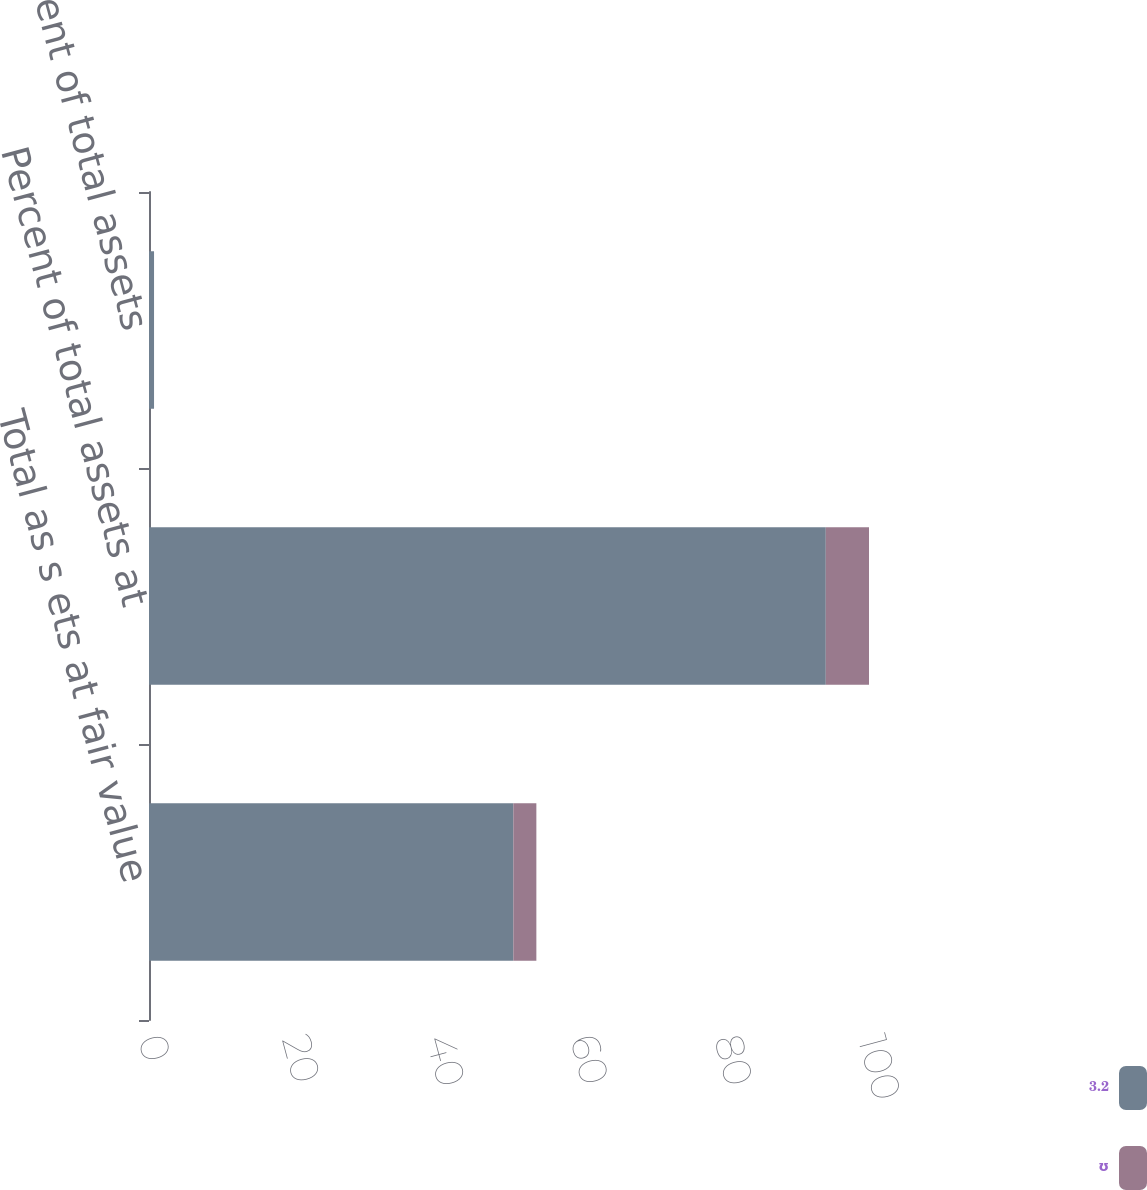<chart> <loc_0><loc_0><loc_500><loc_500><stacked_bar_chart><ecel><fcel>Total as s ets at fair value<fcel>Percent of total assets at<fcel>Percent of total assets<nl><fcel>3.2<fcel>50.6<fcel>94<fcel>0.7<nl><fcel>ʊ<fcel>3.2<fcel>6<fcel>0<nl></chart> 